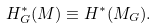Convert formula to latex. <formula><loc_0><loc_0><loc_500><loc_500>H _ { G } ^ { * } ( M ) \equiv H ^ { * } ( M _ { G } ) .</formula> 